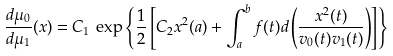<formula> <loc_0><loc_0><loc_500><loc_500>\frac { d \mu _ { 0 } } { d \mu _ { 1 } } ( x ) = C _ { 1 } \, \exp \left \{ \frac { 1 } { 2 } \left [ C _ { 2 } x ^ { 2 } ( a ) + \int _ { a } ^ { b } f ( t ) d \left ( \frac { x ^ { 2 } ( t ) } { v _ { 0 } ( t ) v _ { 1 } ( t ) } \right ) \right ] \right \}</formula> 